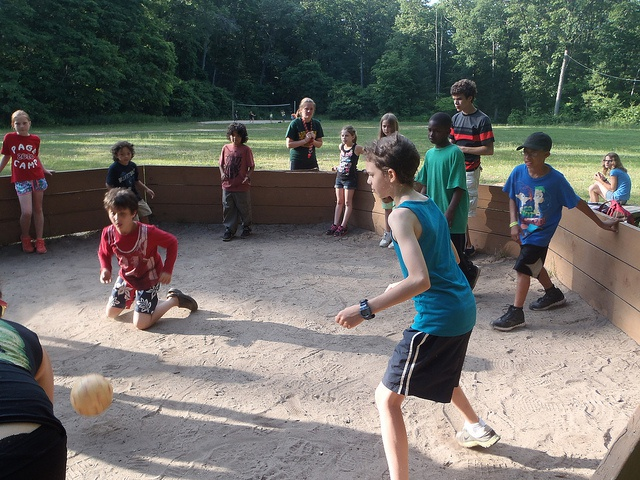Describe the objects in this image and their specific colors. I can see people in black, gray, blue, and lightgray tones, people in black, gray, and darkgray tones, people in black, navy, maroon, and gray tones, people in black, maroon, gray, and brown tones, and people in black and teal tones in this image. 